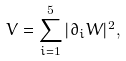<formula> <loc_0><loc_0><loc_500><loc_500>V = \sum _ { i = 1 } ^ { 5 } | \partial _ { i } W | ^ { 2 } ,</formula> 